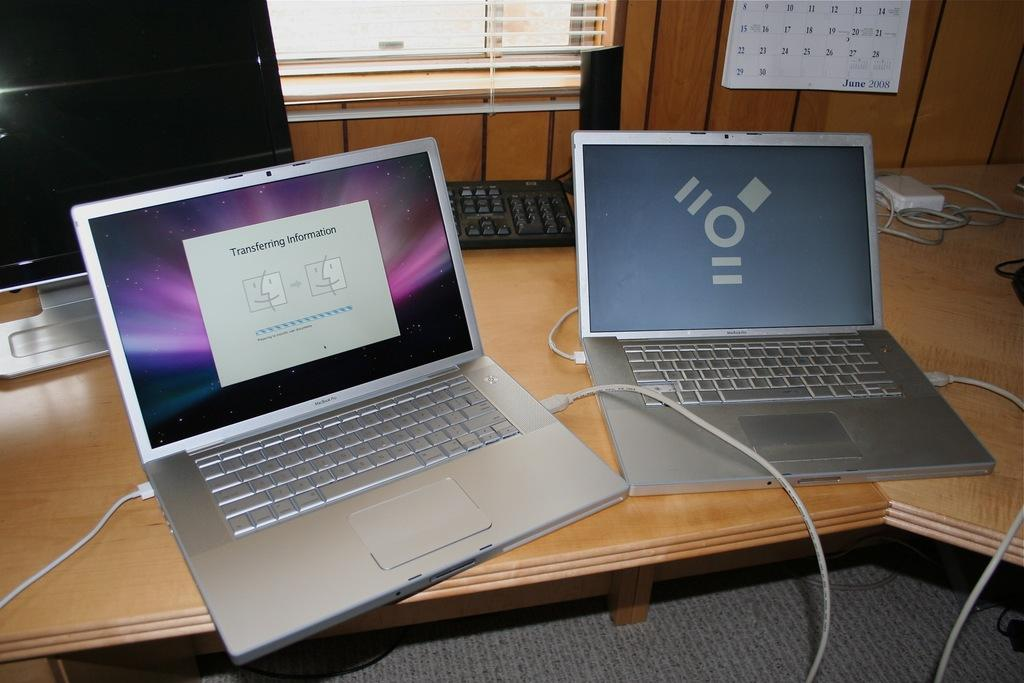<image>
Render a clear and concise summary of the photo. One macbook is transferring information to the other macbook 